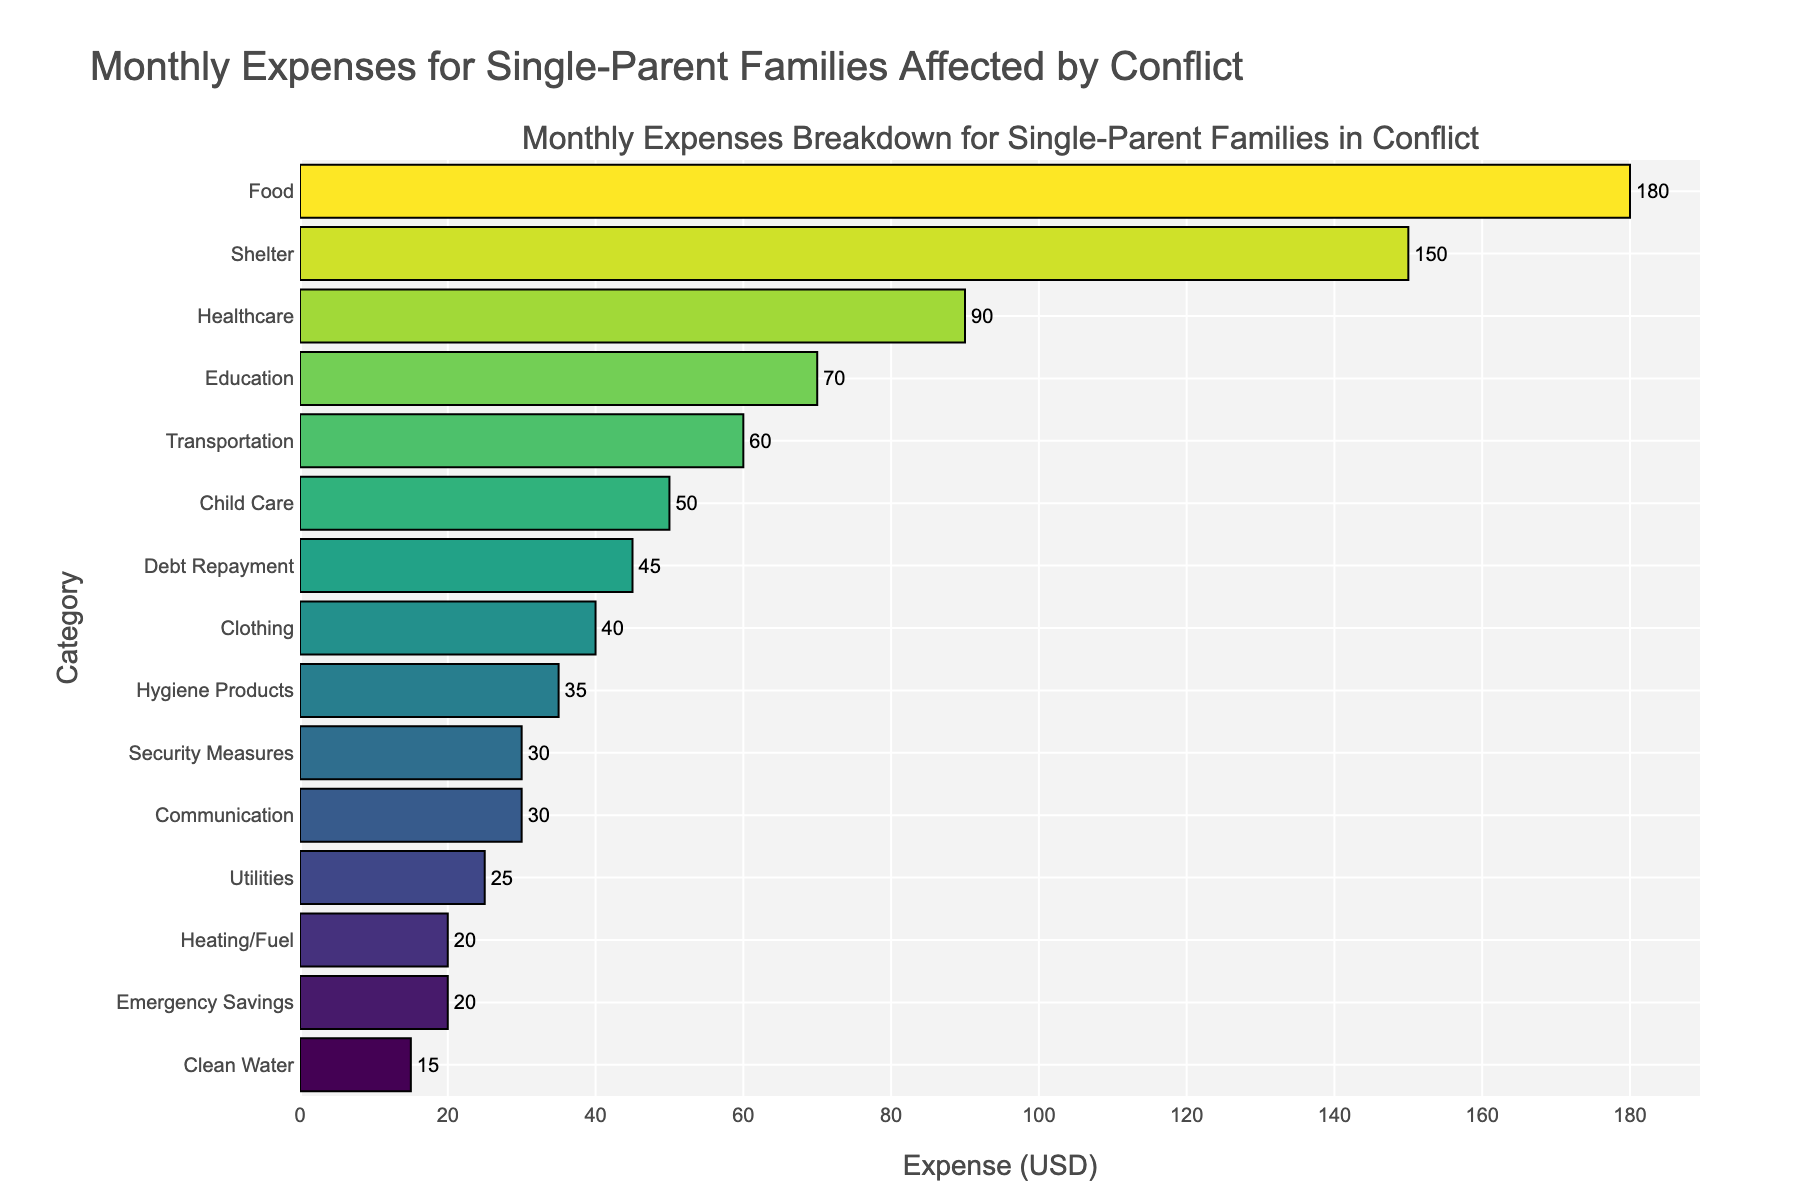Which category has the highest monthly expense? By examining the lengths of the bars, the category with the longest bar has the highest expense. In this case, the "Food" category has the longest bar.
Answer: Food Which category has the lowest monthly expense? By examining the lengths of the bars, the category with the shortest bar has the lowest expense. In this case, the "Clean Water" category has the shortest bar.
Answer: Clean Water What are the total monthly expenses for Food and Shelter combined? Add the expenses of Food and Shelter. Food: $180, Shelter: $150. Total = $180 + $150 = $330.
Answer: $330 How much more is spent on Healthcare compared to Utilities? Subtract the expense of Utilities from the expense of Healthcare. Healthcare: $90, Utilities: $25. Difference = $90 - $25 = $65.
Answer: $65 What is the average monthly expense for Communication, Utilities, and Heating/Fuel? Add the expenses of Communication, Utilities, and Heating/Fuel and divide by 3. Communication: $30, Utilities: $25, Heating/Fuel: $20. Average = ($30 + $25 + $20) / 3 = $75 / 3 = $25.
Answer: $25 How does the expense for Security Measures compare to Clothing? Compare the expense values for Security Measures and Clothing. Security Measures: $30, Clothing: $40. Security Measures has a $10 lower expense compared to Clothing.
Answer: $10 less Which two categories have the closest expenses, and what is the difference between them? Identify the categories with minimal difference. Child Care: $50 and Clothing: $40 have the closest expenses. Difference = $50 - $40 = $10.
Answer: Child Care and Clothing, $10 What percentage of the total monthly expenses is spent on Education? Find the total expense first, then calculate the percentage for Education. Total expense = sum of all categories = $900. Education expense: $70. Percentage = ($70 / $900) * 100 ≈ 7.78%.
Answer: 7.78% How much is spent on Child Care and Education combined, and how does this compare to the expense for Healthcare alone? Add the expenses for Child Care and Education, then compare to Healthcare. Child Care: $50, Education: $70. Combined = $50 + $70 = $120. Healthcare: $90. Comparison: $120 (combined) - $90 (Healthcare) = $30 more for Child Care and Education.
Answer: $30 more If $10 were added to the expense for Hygiene Products, how would it compare to the current expense for Communication? Add $10 to Hygiene Products and compare to Communication. Hygiene Products: $35 + $10 = $45. Communication: $30. $45 is more than $30, so Hygiene Products would be $15 more than Communication.
Answer: $15 more 